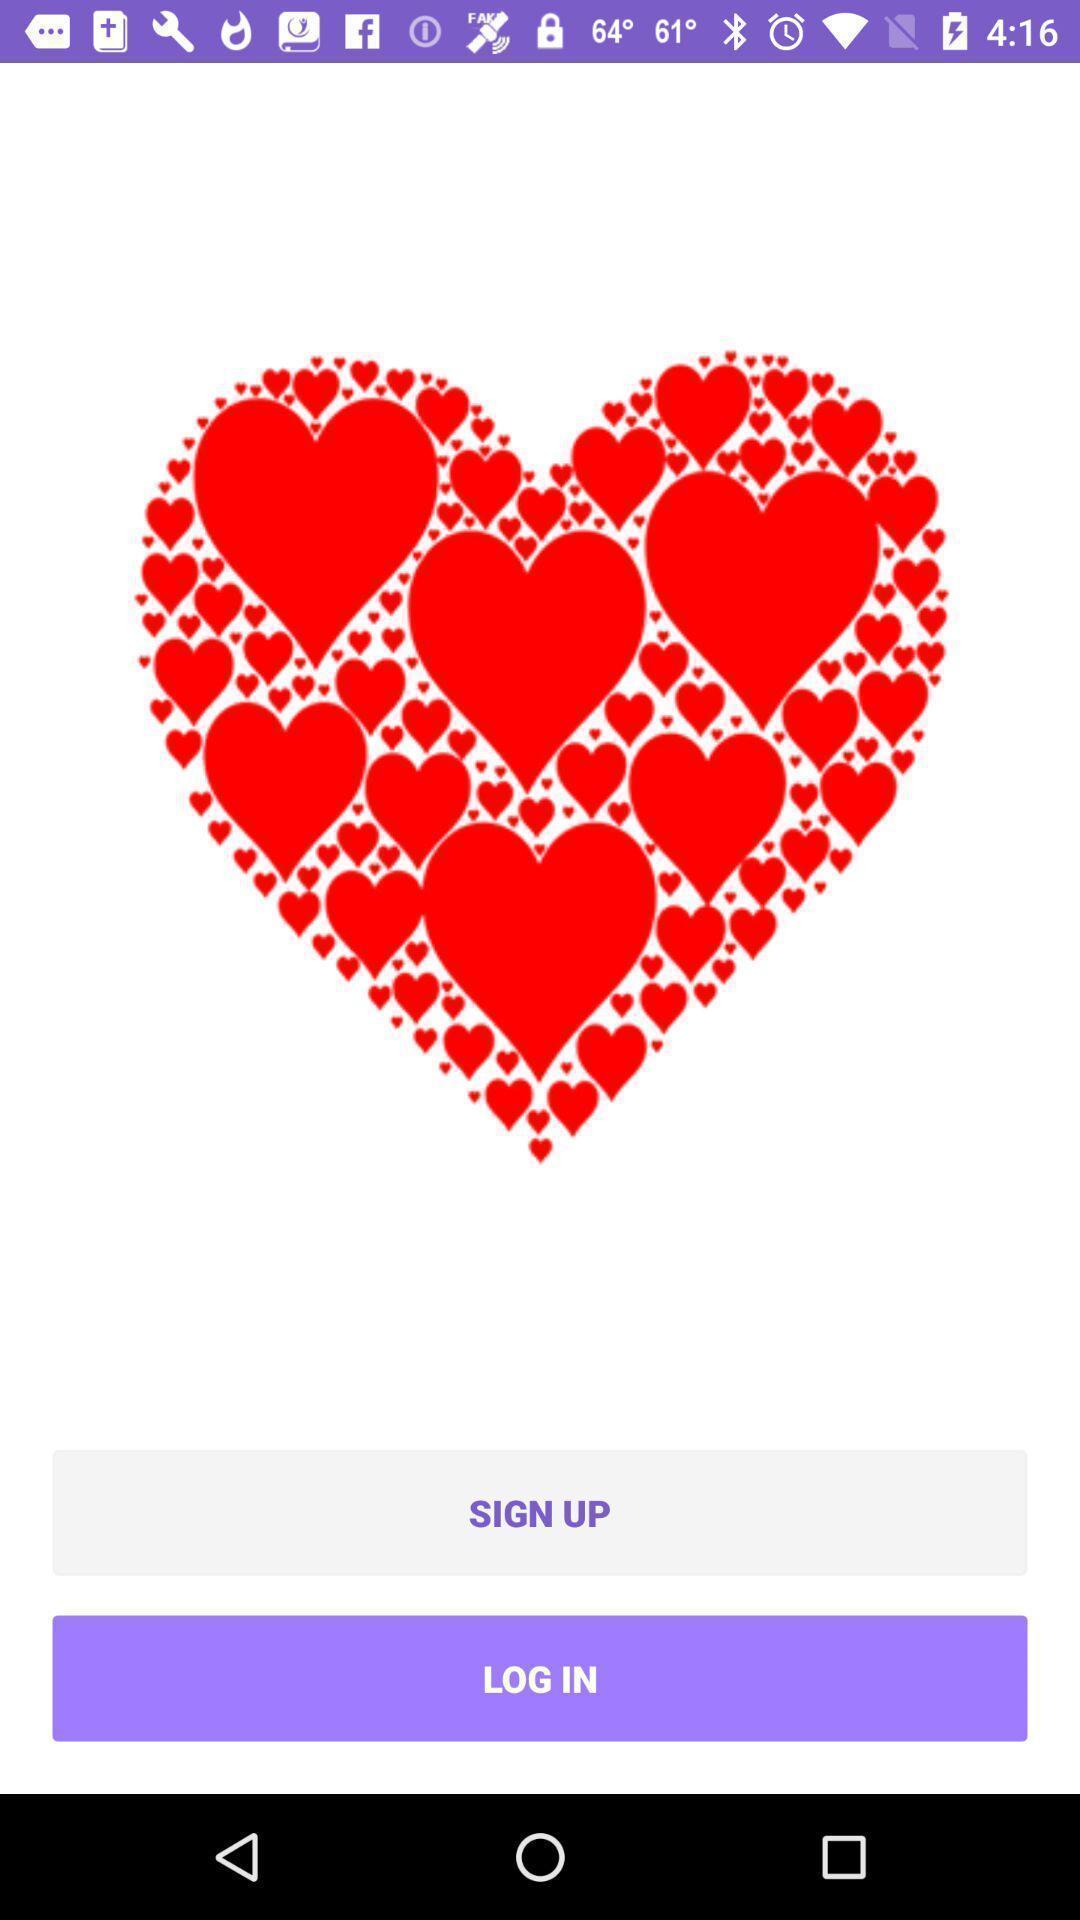What can you discern from this picture? Sign-up page of a social app. 